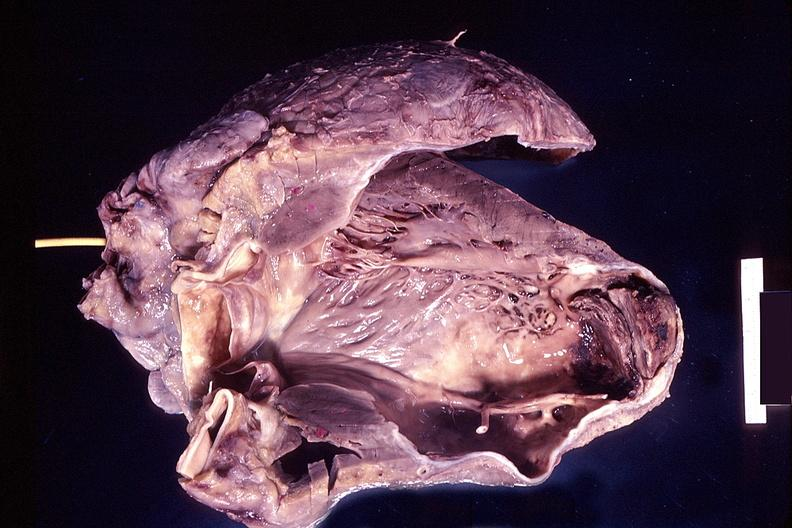does this image show heart, old myocardial infarction with aneurysm formation?
Answer the question using a single word or phrase. Yes 